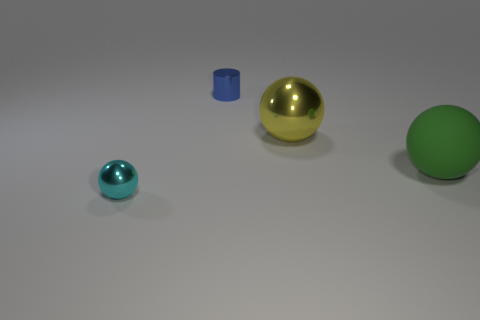Is the shape of the yellow thing the same as the cyan metallic thing?
Give a very brief answer. Yes. What is the color of the tiny metallic thing to the right of the metallic sphere in front of the large yellow sphere?
Keep it short and to the point. Blue. There is a metal thing that is the same size as the shiny cylinder; what color is it?
Your answer should be compact. Cyan. What number of metal objects are either cyan objects or tiny brown cubes?
Keep it short and to the point. 1. What number of small cyan shiny things are to the right of the metal thing behind the yellow metallic object?
Ensure brevity in your answer.  0. How many objects are either big purple objects or tiny things that are behind the matte ball?
Provide a succinct answer. 1. Are there any tiny gray cubes made of the same material as the cylinder?
Provide a short and direct response. No. What number of things are both in front of the blue metal cylinder and behind the big green rubber object?
Ensure brevity in your answer.  1. What material is the ball to the right of the yellow shiny object?
Offer a terse response. Rubber. There is a yellow ball that is made of the same material as the cyan object; what size is it?
Provide a short and direct response. Large. 